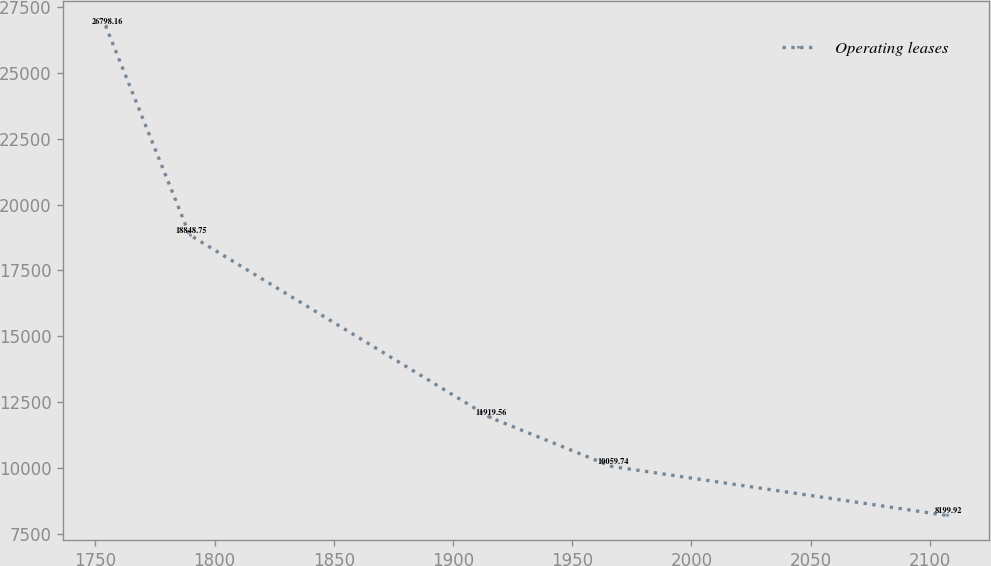<chart> <loc_0><loc_0><loc_500><loc_500><line_chart><ecel><fcel>Operating leases<nl><fcel>1754.21<fcel>26798.2<nl><fcel>1789.49<fcel>18848.8<nl><fcel>1915.49<fcel>11919.6<nl><fcel>1966.38<fcel>10059.7<nl><fcel>2107.02<fcel>8199.92<nl></chart> 